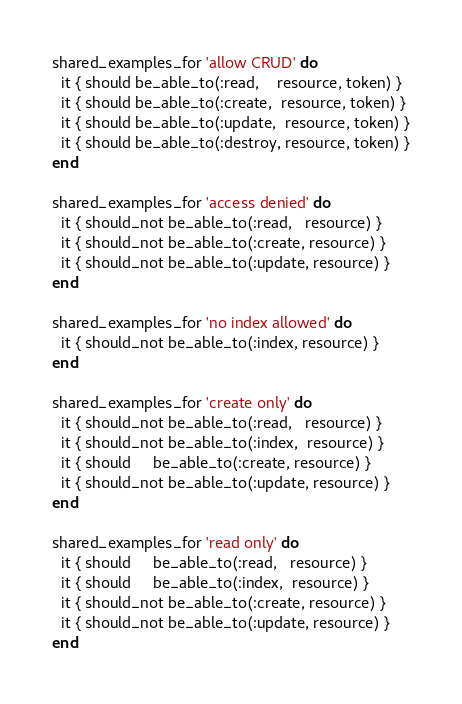Convert code to text. <code><loc_0><loc_0><loc_500><loc_500><_Ruby_>shared_examples_for 'allow CRUD' do
  it { should be_able_to(:read,    resource, token) }
  it { should be_able_to(:create,  resource, token) }
  it { should be_able_to(:update,  resource, token) }
  it { should be_able_to(:destroy, resource, token) }
end

shared_examples_for 'access denied' do
  it { should_not be_able_to(:read,   resource) }
  it { should_not be_able_to(:create, resource) }
  it { should_not be_able_to(:update, resource) }
end

shared_examples_for 'no index allowed' do
  it { should_not be_able_to(:index, resource) }
end

shared_examples_for 'create only' do
  it { should_not be_able_to(:read,   resource) }
  it { should_not be_able_to(:index,  resource) }
  it { should     be_able_to(:create, resource) }
  it { should_not be_able_to(:update, resource) }
end

shared_examples_for 'read only' do
  it { should     be_able_to(:read,   resource) }
  it { should     be_able_to(:index,  resource) }
  it { should_not be_able_to(:create, resource) }
  it { should_not be_able_to(:update, resource) }
end</code> 